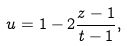Convert formula to latex. <formula><loc_0><loc_0><loc_500><loc_500>u = 1 - 2 \frac { z - 1 } { t - 1 } ,</formula> 